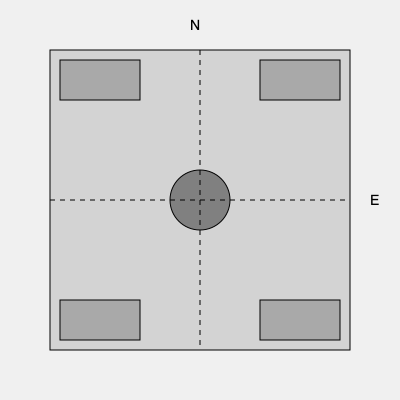Based on the layout of a typical US military base in Vietnam shown above, which direction would an attack from the Ho Chi Minh Trail most likely come from? To answer this question, we need to consider the following steps:

1. Orientation: The diagram shows North at the top and East to the right.

2. Base layout: The base is represented by a square with defensive structures (gray rectangles) at each corner.

3. Ho Chi Minh Trail: This was a network of jungle paths used by North Vietnamese forces to infiltrate South Vietnam. It primarily ran through Laos and Cambodia, along Vietnam's western border.

4. Geography of Vietnam: Vietnam is oriented with the coast to the east and south, and borders with Laos and Cambodia to the west.

5. Likely attack direction: Given that the Ho Chi Minh Trail was to the west of most US bases in Vietnam, attacks would most likely come from that direction.

6. Diagram analysis: In the given layout, west would be on the left side of the diagram.

Therefore, an attack from the Ho Chi Minh Trail would most likely come from the west, which is the left side of the diagram.
Answer: West 